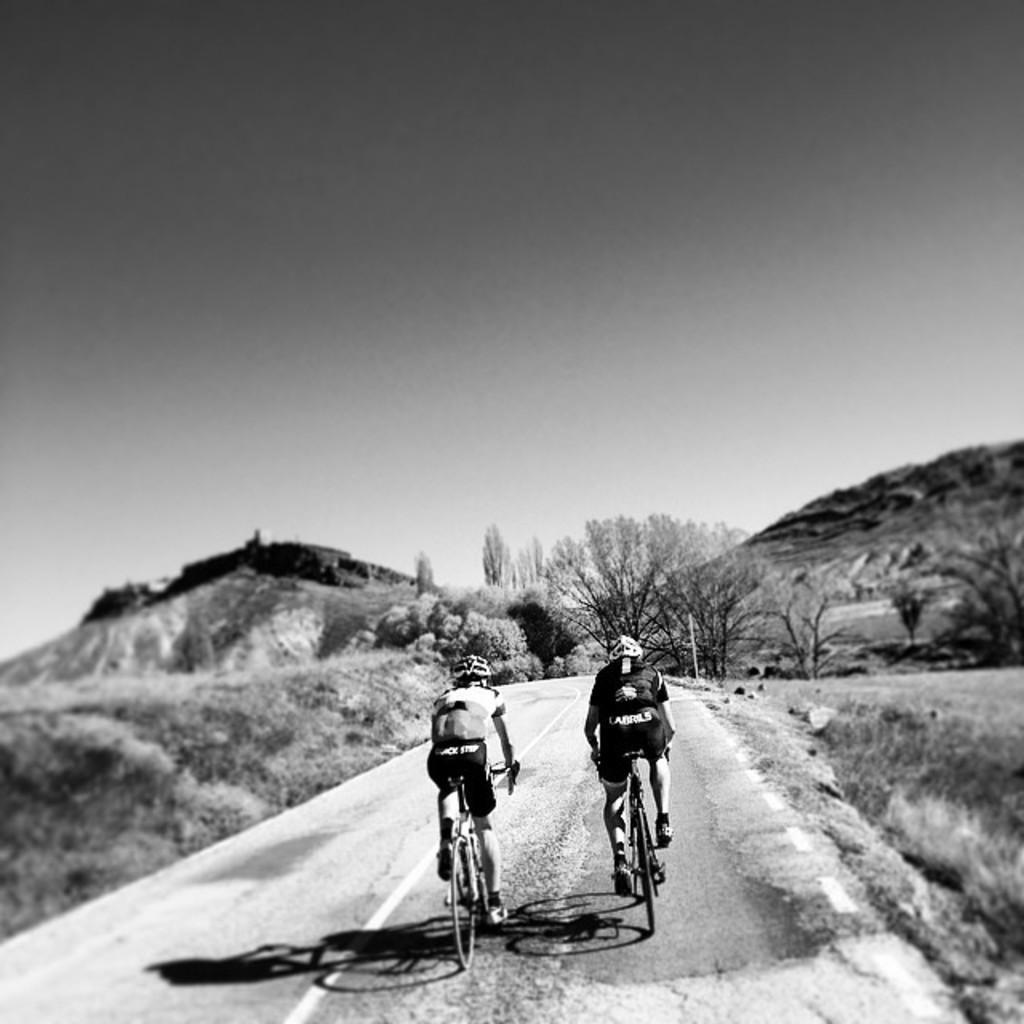Please provide a concise description of this image. This is a black and white image. In this image we can see two persons wearing helmets. They are riding bicycles on the road. In the back there are trees and hills. Also there is sky. 